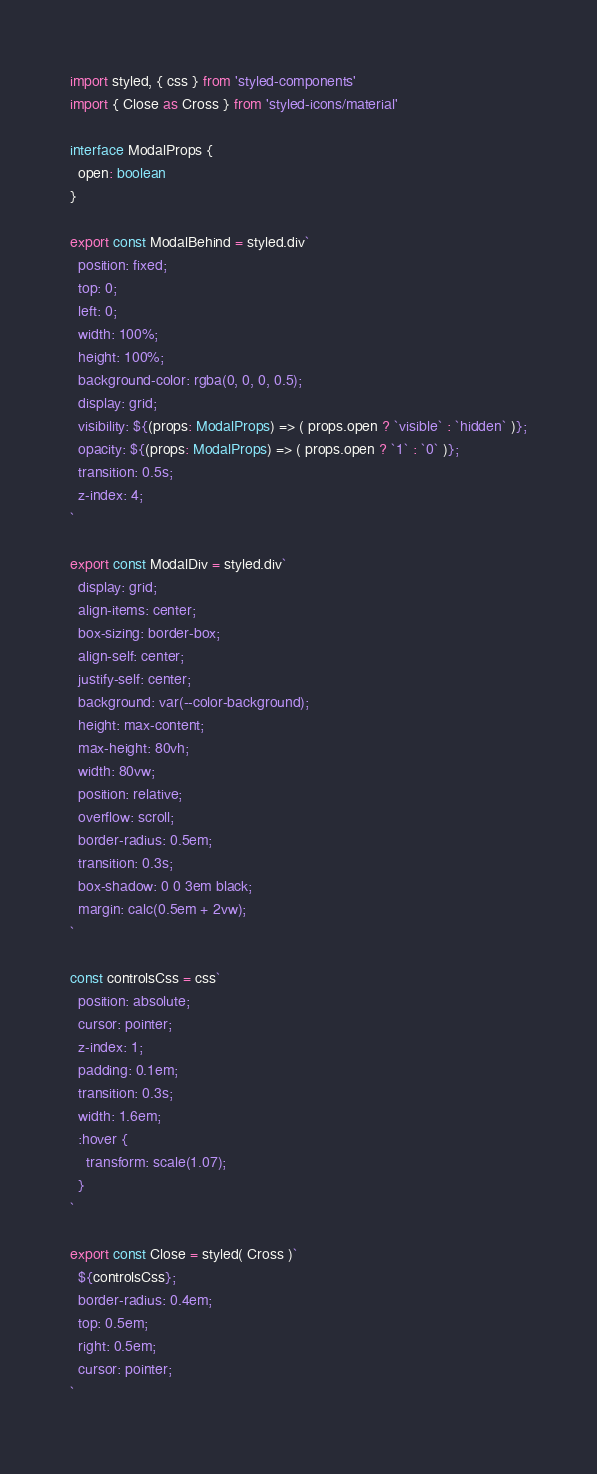<code> <loc_0><loc_0><loc_500><loc_500><_TypeScript_>import styled, { css } from 'styled-components'
import { Close as Cross } from 'styled-icons/material'

interface ModalProps {
  open: boolean
}

export const ModalBehind = styled.div`
  position: fixed;
  top: 0;
  left: 0;
  width: 100%;
  height: 100%;
  background-color: rgba(0, 0, 0, 0.5);
  display: grid;
  visibility: ${(props: ModalProps) => ( props.open ? `visible` : `hidden` )};
  opacity: ${(props: ModalProps) => ( props.open ? `1` : `0` )};
  transition: 0.5s;
  z-index: 4;
`

export const ModalDiv = styled.div`
  display: grid;
  align-items: center;
  box-sizing: border-box;
  align-self: center;
  justify-self: center;
  background: var(--color-background);
  height: max-content;
  max-height: 80vh;
  width: 80vw;
  position: relative;
  overflow: scroll;
  border-radius: 0.5em;
  transition: 0.3s;
  box-shadow: 0 0 3em black;
  margin: calc(0.5em + 2vw);
`

const controlsCss = css`
  position: absolute;
  cursor: pointer;
  z-index: 1;
  padding: 0.1em;
  transition: 0.3s;
  width: 1.6em;
  :hover {
    transform: scale(1.07);
  }
`

export const Close = styled( Cross )`
  ${controlsCss};
  border-radius: 0.4em;
  top: 0.5em;
  right: 0.5em;
  cursor: pointer;
`</code> 